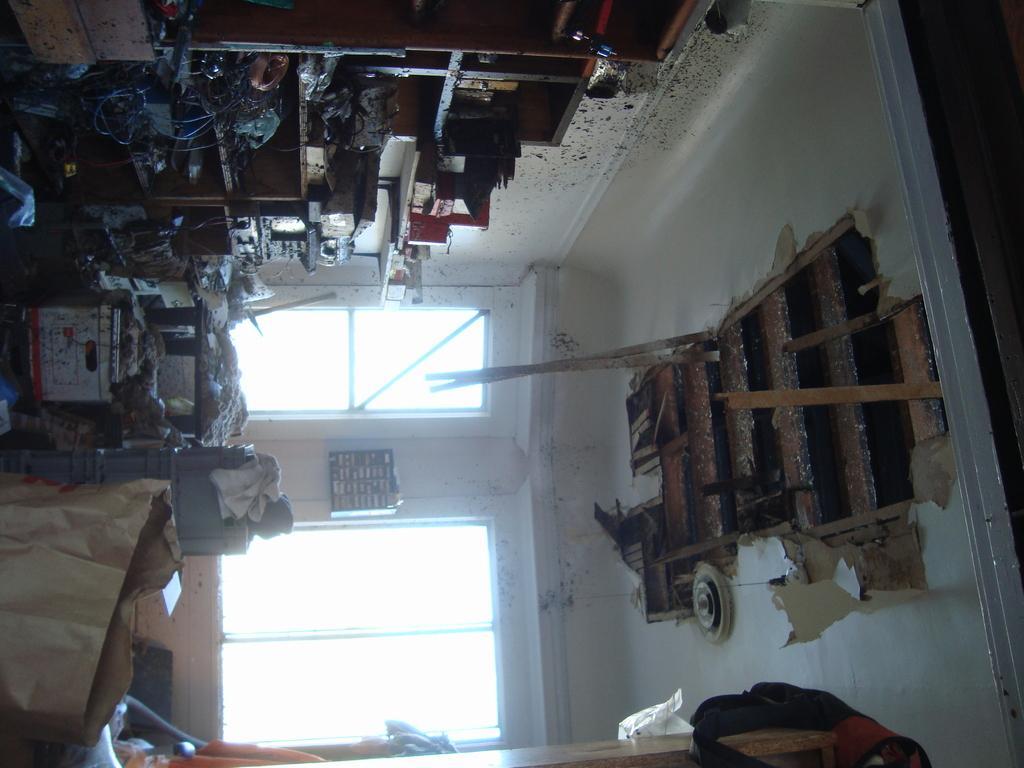In one or two sentences, can you explain what this image depicts? In the picture I can see some objects are placed on the floor, we can see the cupboards, the damaged ceiling and the glass windows in the background. 